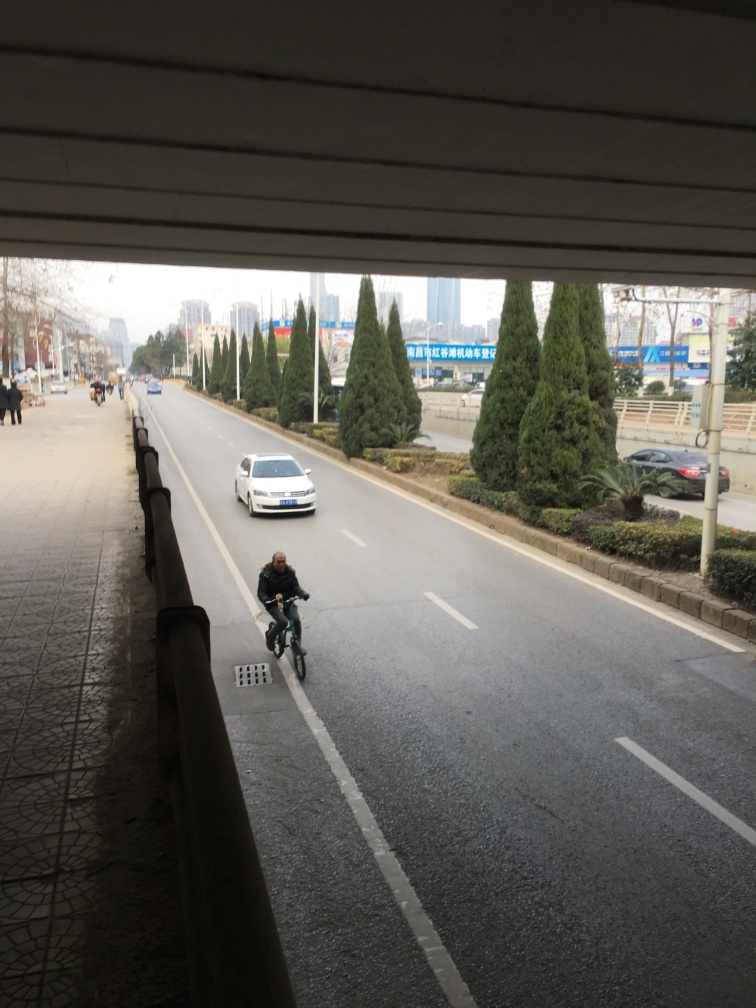Is the lighting too dark? The lighting in the image appears to be natural and sufficient to clearly see the details of the environment, including the vehicles, trees, and road. The shadows suggest it might be a cloudy day or taken during a time when direct sunlight is obstructed, giving an overall soft lighting to the scene. 